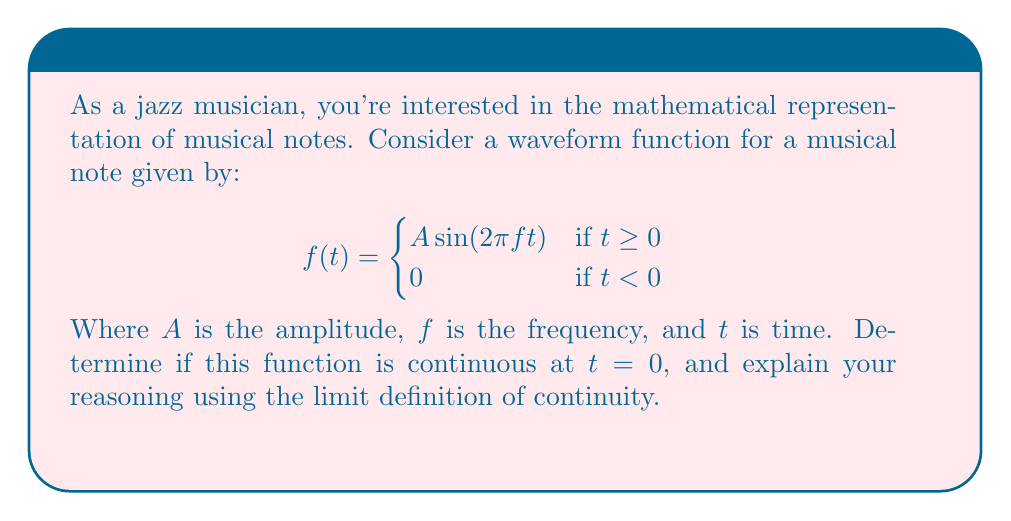Could you help me with this problem? Let's approach this step-by-step using the limit definition of continuity:

1) For a function to be continuous at a point $t = a$, three conditions must be met:
   a) $f(a)$ must exist
   b) $\lim_{t \to a^-} f(t)$ must exist
   c) $\lim_{t \to a^+} f(t)$ must exist
   d) $f(a) = \lim_{t \to a^-} f(t) = \lim_{t \to a^+} f(t)$

2) In our case, we're examining continuity at $t = 0$. Let's check each condition:

   a) $f(0)$ exists: 
      $f(0) = 0$ (using the second piece of the piecewise function)

   b) $\lim_{t \to 0^-} f(t)$:
      As $t$ approaches 0 from the left, $f(t) = 0$
      So, $\lim_{t \to 0^-} f(t) = 0$

   c) $\lim_{t \to 0^+} f(t)$:
      As $t$ approaches 0 from the right, $f(t) = A \sin(2\pi ft)$
      $\lim_{t \to 0^+} A \sin(2\pi ft) = A \sin(0) = 0$

   d) Checking equality:
      $f(0) = 0$
      $\lim_{t \to 0^-} f(t) = 0$
      $\lim_{t \to 0^+} f(t) = 0$

3) Since all conditions are met and all limits equal $f(0)$, the function is continuous at $t = 0$.

This continuity ensures that there's no abrupt jump in the waveform at $t = 0$, which would create an undesirable "click" sound in the musical note.
Answer: The function is continuous at $t = 0$. 